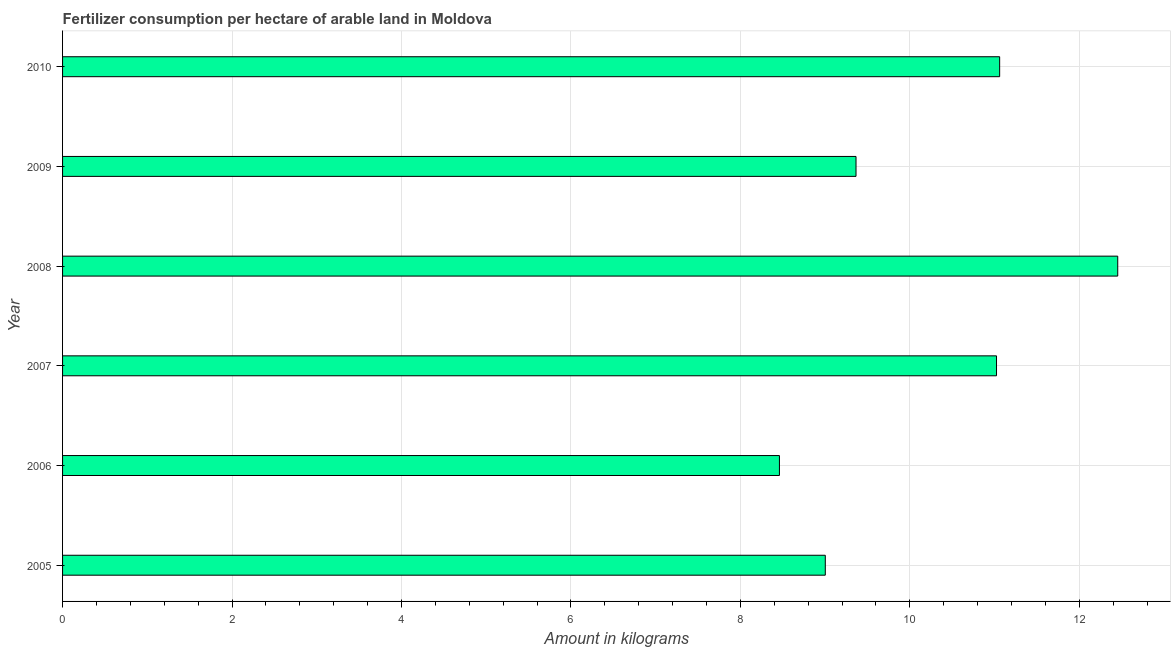What is the title of the graph?
Make the answer very short. Fertilizer consumption per hectare of arable land in Moldova . What is the label or title of the X-axis?
Make the answer very short. Amount in kilograms. What is the amount of fertilizer consumption in 2010?
Make the answer very short. 11.06. Across all years, what is the maximum amount of fertilizer consumption?
Offer a terse response. 12.45. Across all years, what is the minimum amount of fertilizer consumption?
Offer a very short reply. 8.46. In which year was the amount of fertilizer consumption maximum?
Make the answer very short. 2008. What is the sum of the amount of fertilizer consumption?
Give a very brief answer. 61.36. What is the difference between the amount of fertilizer consumption in 2008 and 2009?
Keep it short and to the point. 3.09. What is the average amount of fertilizer consumption per year?
Ensure brevity in your answer.  10.23. What is the median amount of fertilizer consumption?
Your answer should be compact. 10.19. In how many years, is the amount of fertilizer consumption greater than 9.6 kg?
Offer a terse response. 3. What is the ratio of the amount of fertilizer consumption in 2006 to that in 2007?
Give a very brief answer. 0.77. What is the difference between the highest and the second highest amount of fertilizer consumption?
Provide a short and direct response. 1.39. Is the sum of the amount of fertilizer consumption in 2008 and 2010 greater than the maximum amount of fertilizer consumption across all years?
Make the answer very short. Yes. What is the difference between the highest and the lowest amount of fertilizer consumption?
Keep it short and to the point. 3.99. How many bars are there?
Give a very brief answer. 6. Are the values on the major ticks of X-axis written in scientific E-notation?
Your answer should be very brief. No. What is the Amount in kilograms in 2005?
Your answer should be compact. 9. What is the Amount in kilograms of 2006?
Your response must be concise. 8.46. What is the Amount in kilograms in 2007?
Make the answer very short. 11.02. What is the Amount in kilograms in 2008?
Your answer should be compact. 12.45. What is the Amount in kilograms in 2009?
Offer a terse response. 9.36. What is the Amount in kilograms of 2010?
Your answer should be compact. 11.06. What is the difference between the Amount in kilograms in 2005 and 2006?
Your answer should be very brief. 0.54. What is the difference between the Amount in kilograms in 2005 and 2007?
Your answer should be very brief. -2.02. What is the difference between the Amount in kilograms in 2005 and 2008?
Your answer should be compact. -3.45. What is the difference between the Amount in kilograms in 2005 and 2009?
Make the answer very short. -0.36. What is the difference between the Amount in kilograms in 2005 and 2010?
Provide a short and direct response. -2.06. What is the difference between the Amount in kilograms in 2006 and 2007?
Your response must be concise. -2.56. What is the difference between the Amount in kilograms in 2006 and 2008?
Your response must be concise. -3.99. What is the difference between the Amount in kilograms in 2006 and 2009?
Give a very brief answer. -0.9. What is the difference between the Amount in kilograms in 2006 and 2010?
Keep it short and to the point. -2.6. What is the difference between the Amount in kilograms in 2007 and 2008?
Make the answer very short. -1.43. What is the difference between the Amount in kilograms in 2007 and 2009?
Your answer should be very brief. 1.66. What is the difference between the Amount in kilograms in 2007 and 2010?
Give a very brief answer. -0.04. What is the difference between the Amount in kilograms in 2008 and 2009?
Keep it short and to the point. 3.09. What is the difference between the Amount in kilograms in 2008 and 2010?
Your answer should be compact. 1.39. What is the difference between the Amount in kilograms in 2009 and 2010?
Your answer should be compact. -1.7. What is the ratio of the Amount in kilograms in 2005 to that in 2006?
Keep it short and to the point. 1.06. What is the ratio of the Amount in kilograms in 2005 to that in 2007?
Make the answer very short. 0.82. What is the ratio of the Amount in kilograms in 2005 to that in 2008?
Give a very brief answer. 0.72. What is the ratio of the Amount in kilograms in 2005 to that in 2009?
Provide a short and direct response. 0.96. What is the ratio of the Amount in kilograms in 2005 to that in 2010?
Offer a very short reply. 0.81. What is the ratio of the Amount in kilograms in 2006 to that in 2007?
Keep it short and to the point. 0.77. What is the ratio of the Amount in kilograms in 2006 to that in 2008?
Make the answer very short. 0.68. What is the ratio of the Amount in kilograms in 2006 to that in 2009?
Your response must be concise. 0.9. What is the ratio of the Amount in kilograms in 2006 to that in 2010?
Your answer should be compact. 0.77. What is the ratio of the Amount in kilograms in 2007 to that in 2008?
Keep it short and to the point. 0.89. What is the ratio of the Amount in kilograms in 2007 to that in 2009?
Ensure brevity in your answer.  1.18. What is the ratio of the Amount in kilograms in 2008 to that in 2009?
Your answer should be very brief. 1.33. What is the ratio of the Amount in kilograms in 2008 to that in 2010?
Your answer should be very brief. 1.13. What is the ratio of the Amount in kilograms in 2009 to that in 2010?
Keep it short and to the point. 0.85. 